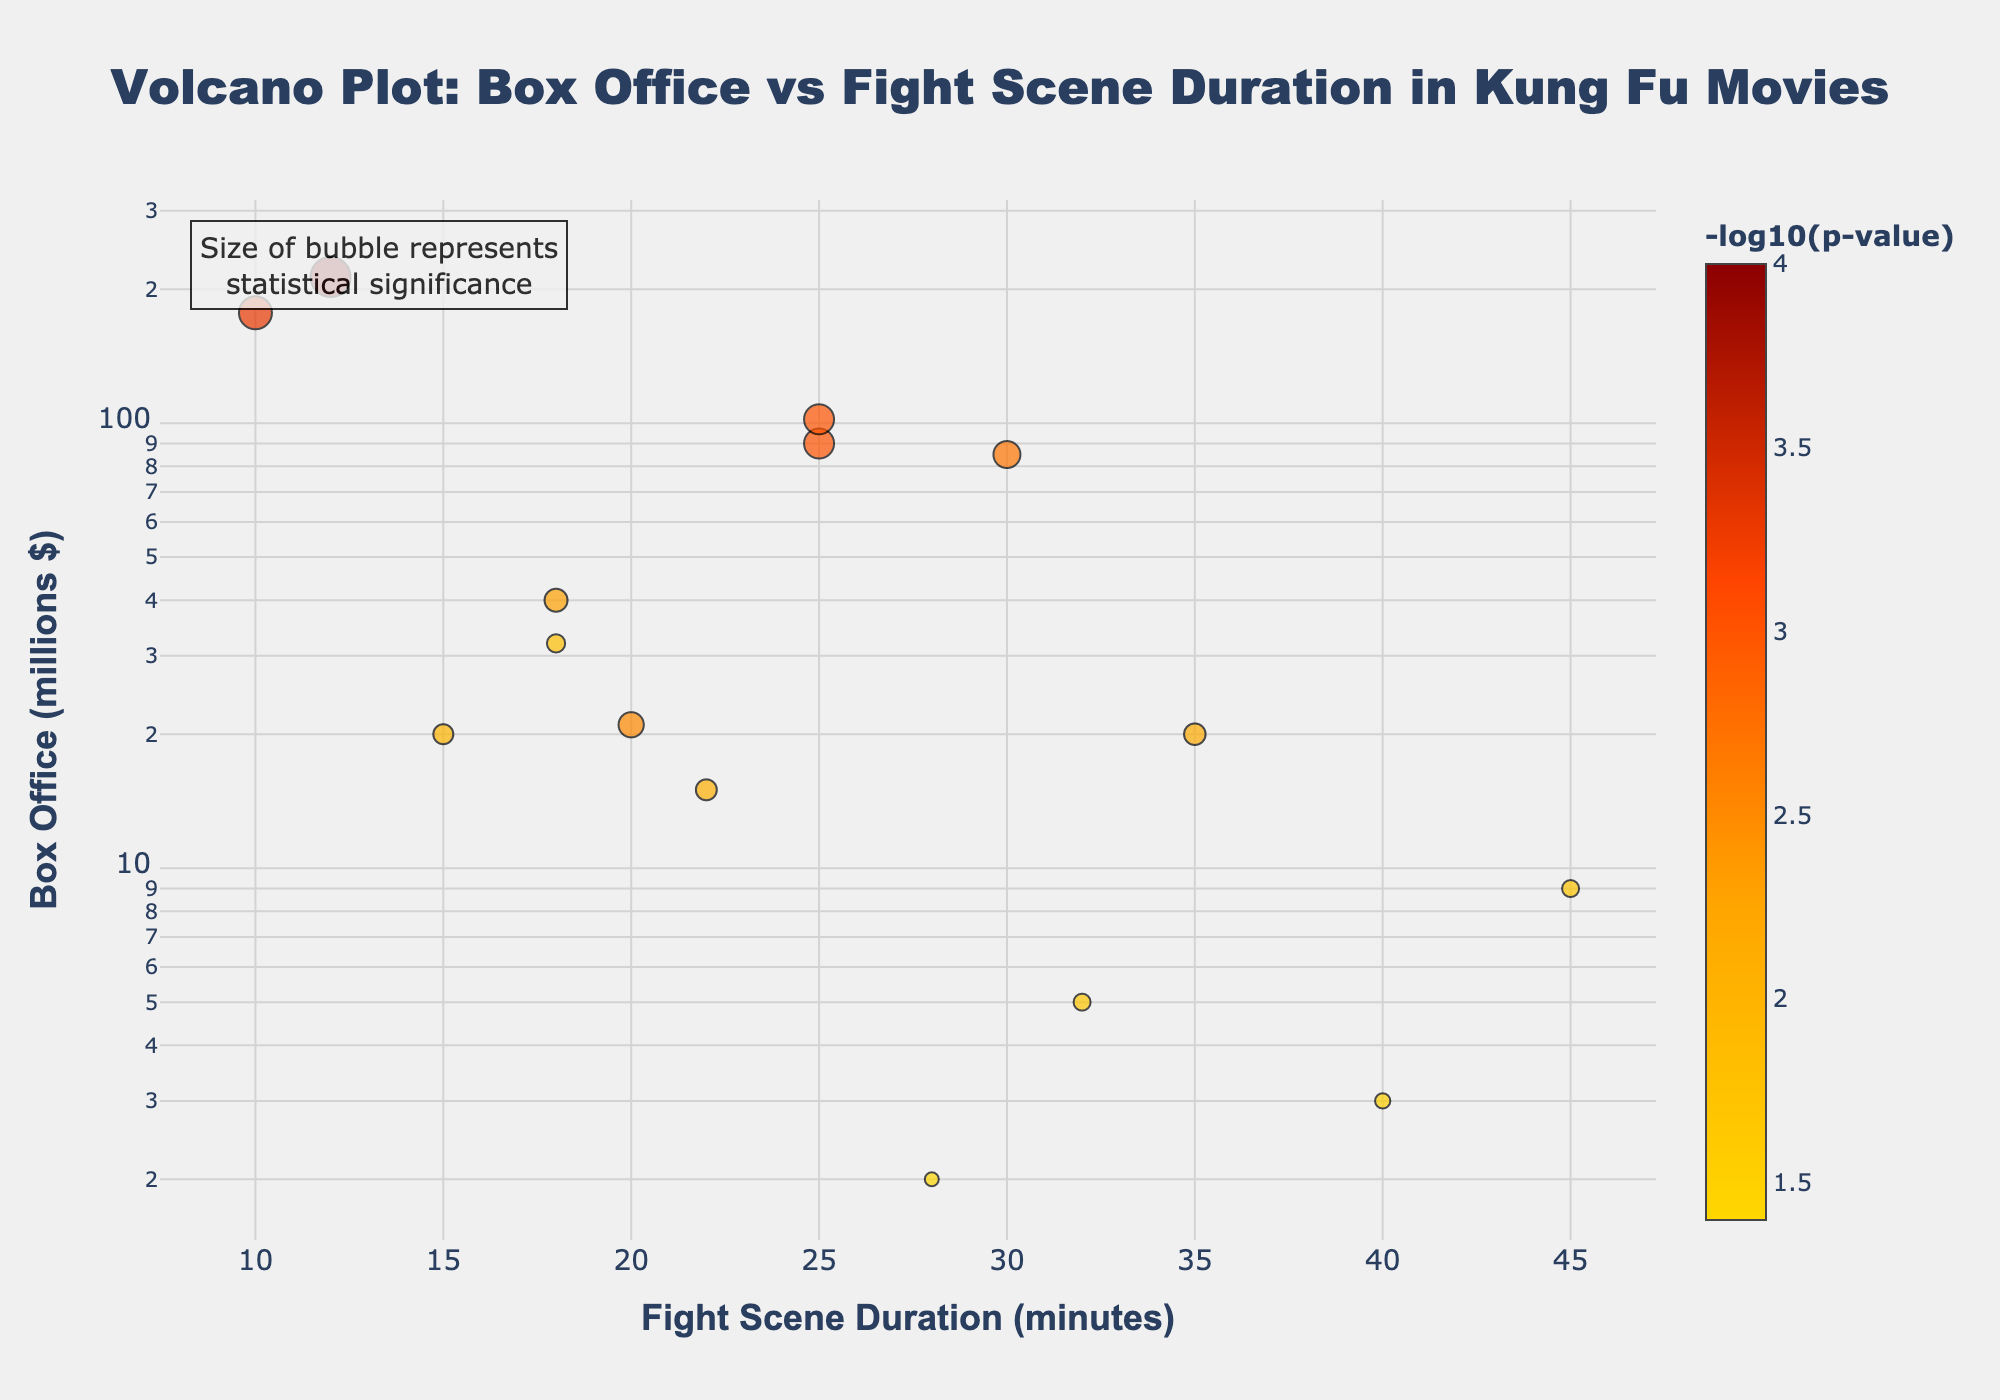What's the title of the plot? The title is displayed at the top of the plot in bold and larger font size compared to other text elements. It reads "<b>Volcano Plot: Box Office vs Fight Scene Duration in Kung Fu Movies</b>".
Answer: Volcano Plot: Box Office vs Fight Scene Duration in Kung Fu Movies What are the axes labels of the plot? The x-axis and y-axis labels are identified near the respective axes in bold text. The x-axis is labeled as "<b>Fight Scene Duration (minutes)</b>" and the y-axis is labeled as "<b>Box Office (millions $)</b>".
Answer: Fight Scene Duration (minutes), Box Office (millions $) How many movies have a fight scene duration of more than 30 minutes? By examining the x-axis for all data points beyond the 30-minute mark and counting them, we find there are three movies: "The 36th Chamber of Shaolin", "Ong-Bak", and "The Raid: Redemption".
Answer: 3 Which movie has the highest box office with a fight scene duration of less than 20 minutes? Reviewing the points under the 20-minute mark (x-axis) and then checking the y-axis values (box office), the movie "Crouching Tiger Hidden Dragon" has the highest box office with $213 million.
Answer: Crouching Tiger Hidden Dragon What does the size of the bubbles in the plot represent? The plot has a custom annotation stating "Size of bubble represents statistical significance". Therefore, bubble size corresponds to the statistical significance measured by -log10(p-value).
Answer: Statistical significance Which movie has the most statistically significant correlation between box office and fight scene duration? The most statistically significant correlation corresponds to the largest bubble size, which we can confirm by the marker color representing -log10(p-value). The largest bubble, and hence the highest significance, belongs to "Crouching Tiger Hidden Dragon".
Answer: Crouching Tiger Hidden Dragon Is there a general trend between fight scene duration and box office performance based on the plot? Observing the distribution of points, there's no linear trend indicating that longer fight scene duration consistently leads to higher box office or vice versa. High box office movies appear at both shorter and medium fight scene durations.
Answer: No clear trend Which two movies have similar box office performances but significantly different fight scene durations? Comparing the y-axis values and noting similar box office collections but varied x-axis positions, "Enter the Dragon" (90 million) and "The Way of the Dragon" (85 million) stand out with significantly different fight durations of 25 and 30 minutes, respectively.
Answer: Enter the Dragon and The Way of the Dragon What is the range of -log10(p-value) in the plot? By reviewing the colorbar on the right side of the plot and interpreting the minimum and maximum values represented by bubble colors and sizes, the range of -log10(p-value) spans from approximately 1.397 (for p=0.04) to 4 (for p=0.0001).
Answer: Approximately 1.397 to 4 